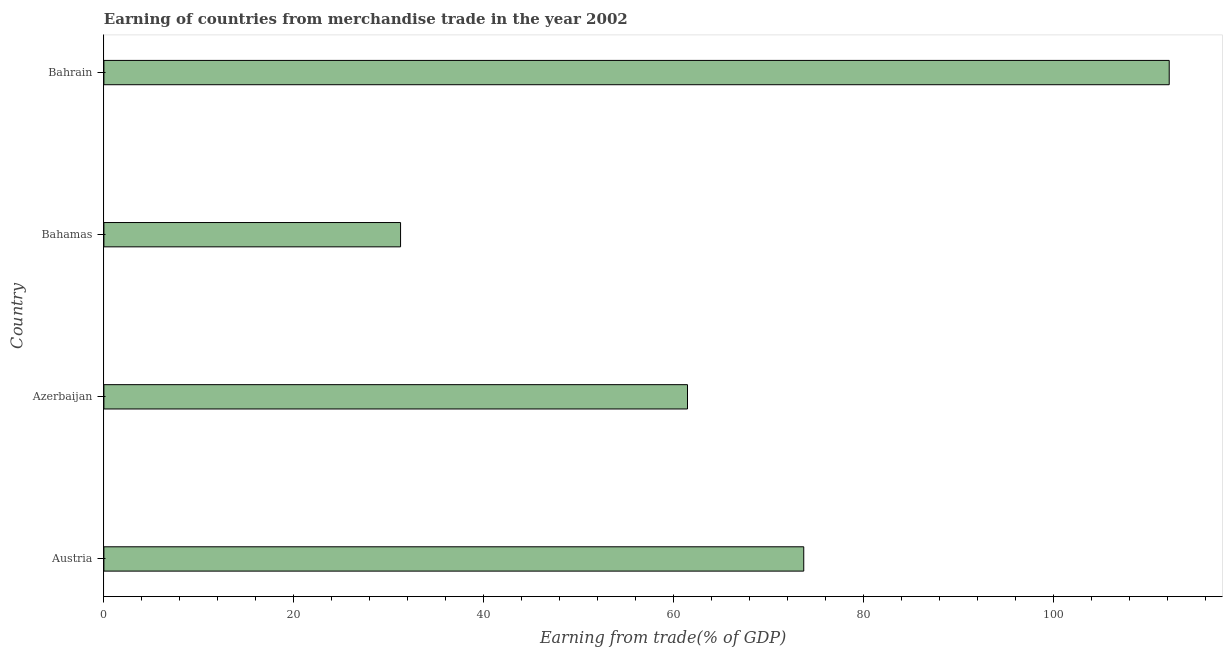Does the graph contain any zero values?
Give a very brief answer. No. Does the graph contain grids?
Keep it short and to the point. No. What is the title of the graph?
Keep it short and to the point. Earning of countries from merchandise trade in the year 2002. What is the label or title of the X-axis?
Keep it short and to the point. Earning from trade(% of GDP). What is the label or title of the Y-axis?
Your answer should be very brief. Country. What is the earning from merchandise trade in Bahrain?
Give a very brief answer. 112.2. Across all countries, what is the maximum earning from merchandise trade?
Keep it short and to the point. 112.2. Across all countries, what is the minimum earning from merchandise trade?
Your response must be concise. 31.24. In which country was the earning from merchandise trade maximum?
Your answer should be compact. Bahrain. In which country was the earning from merchandise trade minimum?
Provide a succinct answer. Bahamas. What is the sum of the earning from merchandise trade?
Ensure brevity in your answer.  278.61. What is the difference between the earning from merchandise trade in Azerbaijan and Bahamas?
Your response must be concise. 30.22. What is the average earning from merchandise trade per country?
Give a very brief answer. 69.65. What is the median earning from merchandise trade?
Offer a terse response. 67.58. In how many countries, is the earning from merchandise trade greater than 52 %?
Offer a very short reply. 3. What is the ratio of the earning from merchandise trade in Azerbaijan to that in Bahrain?
Make the answer very short. 0.55. Is the earning from merchandise trade in Austria less than that in Bahrain?
Provide a succinct answer. Yes. Is the difference between the earning from merchandise trade in Bahamas and Bahrain greater than the difference between any two countries?
Provide a short and direct response. Yes. What is the difference between the highest and the second highest earning from merchandise trade?
Your response must be concise. 38.49. What is the difference between the highest and the lowest earning from merchandise trade?
Make the answer very short. 80.95. In how many countries, is the earning from merchandise trade greater than the average earning from merchandise trade taken over all countries?
Offer a very short reply. 2. How many bars are there?
Give a very brief answer. 4. Are all the bars in the graph horizontal?
Give a very brief answer. Yes. How many countries are there in the graph?
Your answer should be compact. 4. Are the values on the major ticks of X-axis written in scientific E-notation?
Keep it short and to the point. No. What is the Earning from trade(% of GDP) of Austria?
Give a very brief answer. 73.71. What is the Earning from trade(% of GDP) in Azerbaijan?
Give a very brief answer. 61.46. What is the Earning from trade(% of GDP) in Bahamas?
Provide a succinct answer. 31.24. What is the Earning from trade(% of GDP) of Bahrain?
Offer a terse response. 112.2. What is the difference between the Earning from trade(% of GDP) in Austria and Azerbaijan?
Offer a very short reply. 12.24. What is the difference between the Earning from trade(% of GDP) in Austria and Bahamas?
Ensure brevity in your answer.  42.46. What is the difference between the Earning from trade(% of GDP) in Austria and Bahrain?
Provide a succinct answer. -38.49. What is the difference between the Earning from trade(% of GDP) in Azerbaijan and Bahamas?
Offer a terse response. 30.22. What is the difference between the Earning from trade(% of GDP) in Azerbaijan and Bahrain?
Provide a short and direct response. -50.73. What is the difference between the Earning from trade(% of GDP) in Bahamas and Bahrain?
Make the answer very short. -80.95. What is the ratio of the Earning from trade(% of GDP) in Austria to that in Azerbaijan?
Offer a very short reply. 1.2. What is the ratio of the Earning from trade(% of GDP) in Austria to that in Bahamas?
Your answer should be compact. 2.36. What is the ratio of the Earning from trade(% of GDP) in Austria to that in Bahrain?
Provide a short and direct response. 0.66. What is the ratio of the Earning from trade(% of GDP) in Azerbaijan to that in Bahamas?
Provide a succinct answer. 1.97. What is the ratio of the Earning from trade(% of GDP) in Azerbaijan to that in Bahrain?
Your answer should be very brief. 0.55. What is the ratio of the Earning from trade(% of GDP) in Bahamas to that in Bahrain?
Your answer should be compact. 0.28. 